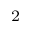Convert formula to latex. <formula><loc_0><loc_0><loc_500><loc_500>_ { 2 }</formula> 